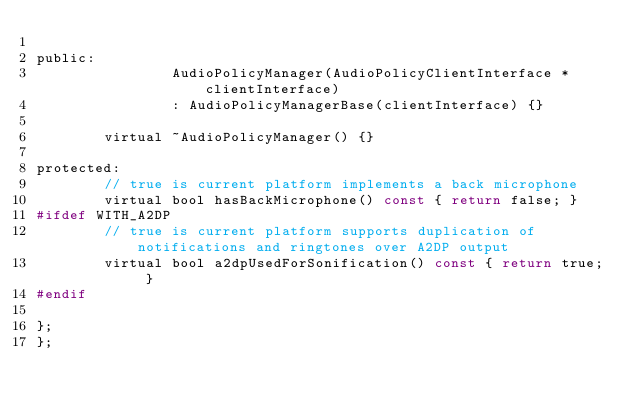<code> <loc_0><loc_0><loc_500><loc_500><_C_>
public:
                AudioPolicyManager(AudioPolicyClientInterface *clientInterface)
                : AudioPolicyManagerBase(clientInterface) {}

        virtual ~AudioPolicyManager() {}

protected:
        // true is current platform implements a back microphone
        virtual bool hasBackMicrophone() const { return false; }
#ifdef WITH_A2DP
        // true is current platform supports duplication of notifications and ringtones over A2DP output
        virtual bool a2dpUsedForSonification() const { return true; }
#endif

};
};
</code> 